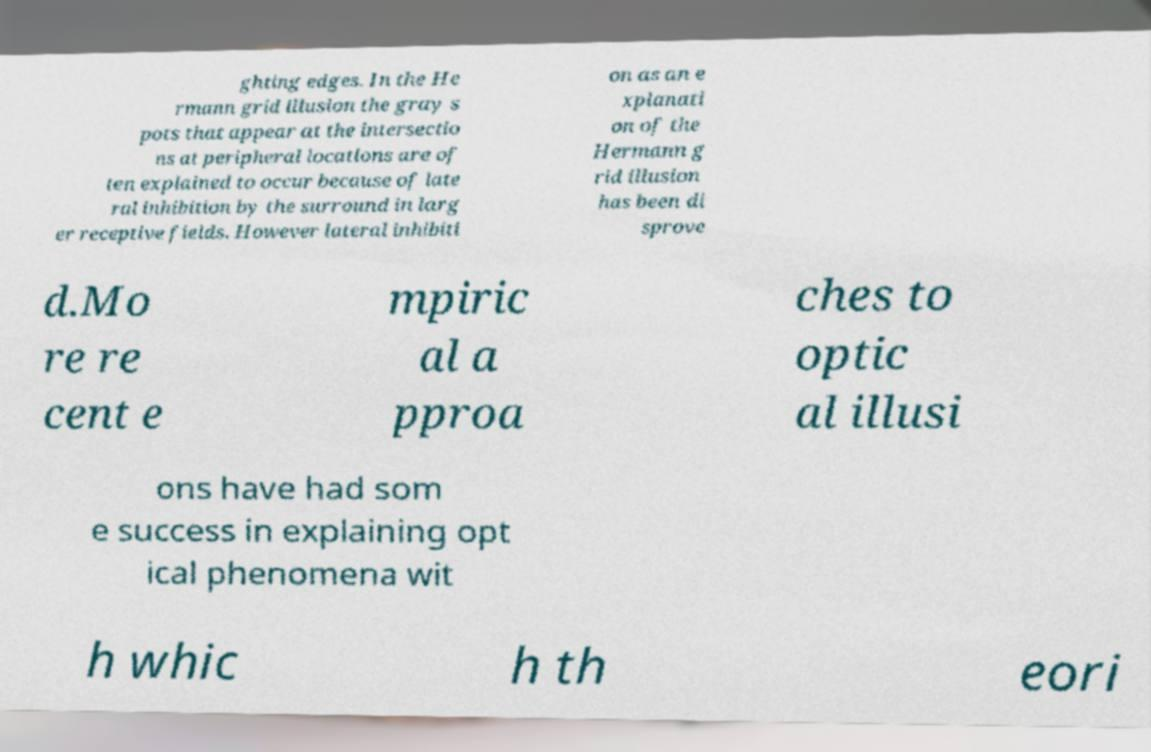Please identify and transcribe the text found in this image. ghting edges. In the He rmann grid illusion the gray s pots that appear at the intersectio ns at peripheral locations are of ten explained to occur because of late ral inhibition by the surround in larg er receptive fields. However lateral inhibiti on as an e xplanati on of the Hermann g rid illusion has been di sprove d.Mo re re cent e mpiric al a pproa ches to optic al illusi ons have had som e success in explaining opt ical phenomena wit h whic h th eori 